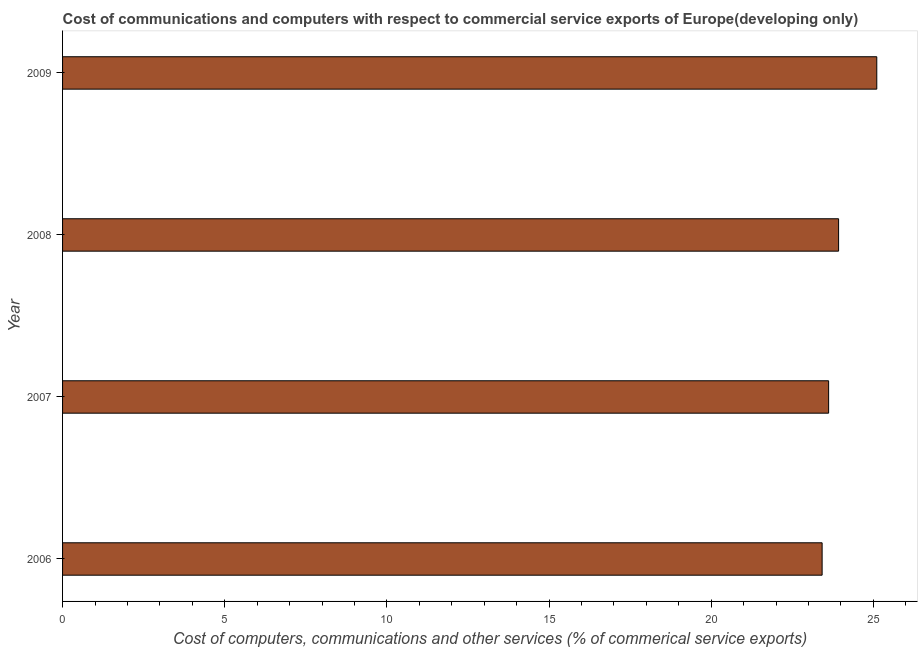What is the title of the graph?
Offer a very short reply. Cost of communications and computers with respect to commercial service exports of Europe(developing only). What is the label or title of the X-axis?
Provide a short and direct response. Cost of computers, communications and other services (% of commerical service exports). What is the label or title of the Y-axis?
Your answer should be compact. Year. What is the cost of communications in 2007?
Make the answer very short. 23.62. Across all years, what is the maximum cost of communications?
Your answer should be compact. 25.11. Across all years, what is the minimum cost of communications?
Make the answer very short. 23.42. In which year was the cost of communications minimum?
Ensure brevity in your answer.  2006. What is the sum of the  computer and other services?
Give a very brief answer. 96.07. What is the difference between the cost of communications in 2007 and 2009?
Provide a short and direct response. -1.49. What is the average  computer and other services per year?
Offer a very short reply. 24.02. What is the median  computer and other services?
Offer a very short reply. 23.77. In how many years, is the  computer and other services greater than 22 %?
Offer a very short reply. 4. Do a majority of the years between 2009 and 2007 (inclusive) have cost of communications greater than 6 %?
Provide a succinct answer. Yes. What is the ratio of the  computer and other services in 2008 to that in 2009?
Offer a terse response. 0.95. What is the difference between the highest and the second highest cost of communications?
Your answer should be very brief. 1.18. Is the sum of the cost of communications in 2006 and 2009 greater than the maximum cost of communications across all years?
Provide a succinct answer. Yes. What is the difference between the highest and the lowest  computer and other services?
Your response must be concise. 1.69. In how many years, is the cost of communications greater than the average cost of communications taken over all years?
Provide a succinct answer. 1. How many bars are there?
Keep it short and to the point. 4. Are all the bars in the graph horizontal?
Offer a very short reply. Yes. How many years are there in the graph?
Offer a very short reply. 4. What is the difference between two consecutive major ticks on the X-axis?
Provide a succinct answer. 5. Are the values on the major ticks of X-axis written in scientific E-notation?
Your answer should be compact. No. What is the Cost of computers, communications and other services (% of commerical service exports) of 2006?
Offer a very short reply. 23.42. What is the Cost of computers, communications and other services (% of commerical service exports) of 2007?
Ensure brevity in your answer.  23.62. What is the Cost of computers, communications and other services (% of commerical service exports) in 2008?
Your answer should be compact. 23.93. What is the Cost of computers, communications and other services (% of commerical service exports) in 2009?
Ensure brevity in your answer.  25.11. What is the difference between the Cost of computers, communications and other services (% of commerical service exports) in 2006 and 2007?
Keep it short and to the point. -0.2. What is the difference between the Cost of computers, communications and other services (% of commerical service exports) in 2006 and 2008?
Give a very brief answer. -0.51. What is the difference between the Cost of computers, communications and other services (% of commerical service exports) in 2006 and 2009?
Give a very brief answer. -1.69. What is the difference between the Cost of computers, communications and other services (% of commerical service exports) in 2007 and 2008?
Give a very brief answer. -0.31. What is the difference between the Cost of computers, communications and other services (% of commerical service exports) in 2007 and 2009?
Offer a very short reply. -1.49. What is the difference between the Cost of computers, communications and other services (% of commerical service exports) in 2008 and 2009?
Provide a succinct answer. -1.18. What is the ratio of the Cost of computers, communications and other services (% of commerical service exports) in 2006 to that in 2009?
Offer a very short reply. 0.93. What is the ratio of the Cost of computers, communications and other services (% of commerical service exports) in 2007 to that in 2009?
Your answer should be very brief. 0.94. What is the ratio of the Cost of computers, communications and other services (% of commerical service exports) in 2008 to that in 2009?
Offer a terse response. 0.95. 